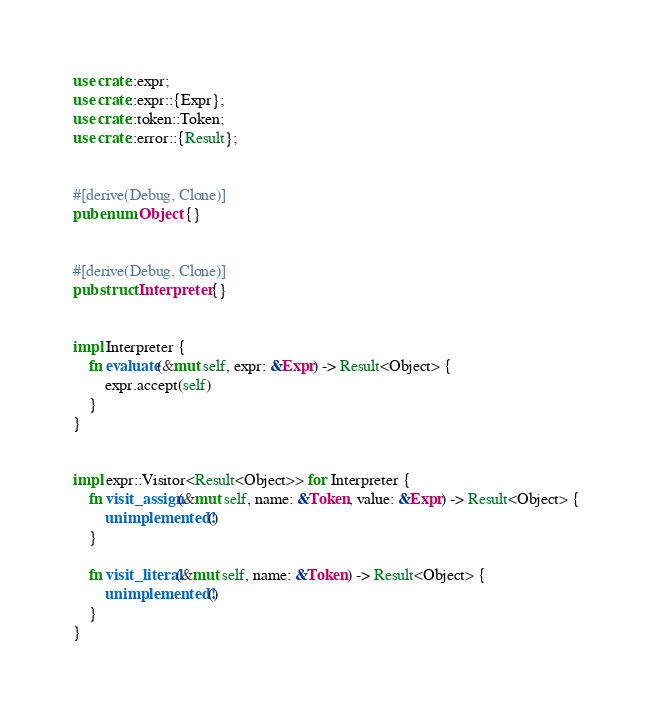Convert code to text. <code><loc_0><loc_0><loc_500><loc_500><_Rust_>use crate::expr;
use crate::expr::{Expr};
use crate::token::Token;
use crate::error::{Result};


#[derive(Debug, Clone)]
pub enum Object {}


#[derive(Debug, Clone)]
pub struct Interpreter {}


impl Interpreter {
    fn evaluate(&mut self, expr: &Expr) -> Result<Object> {
        expr.accept(self)
    }
}


impl expr::Visitor<Result<Object>> for Interpreter {
    fn visit_assign(&mut self, name: &Token, value: &Expr) -> Result<Object> {
        unimplemented!()
    }

    fn visit_literal(&mut self, name: &Token) -> Result<Object> {
        unimplemented!()
    }
}
</code> 